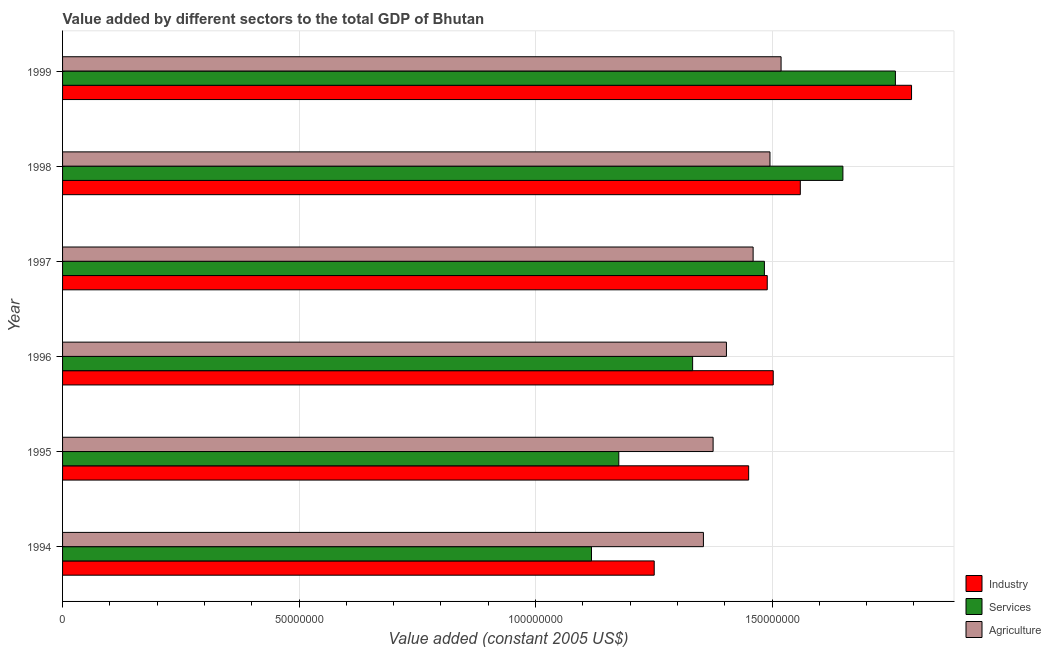Are the number of bars per tick equal to the number of legend labels?
Provide a short and direct response. Yes. Are the number of bars on each tick of the Y-axis equal?
Your answer should be compact. Yes. How many bars are there on the 2nd tick from the top?
Your response must be concise. 3. How many bars are there on the 1st tick from the bottom?
Offer a terse response. 3. What is the value added by industrial sector in 1994?
Your answer should be very brief. 1.25e+08. Across all years, what is the maximum value added by services?
Your answer should be very brief. 1.76e+08. Across all years, what is the minimum value added by agricultural sector?
Provide a short and direct response. 1.35e+08. In which year was the value added by services minimum?
Your answer should be compact. 1994. What is the total value added by services in the graph?
Ensure brevity in your answer.  8.52e+08. What is the difference between the value added by services in 1998 and that in 1999?
Your answer should be compact. -1.11e+07. What is the difference between the value added by agricultural sector in 1998 and the value added by industrial sector in 1995?
Ensure brevity in your answer.  4.51e+06. What is the average value added by industrial sector per year?
Provide a short and direct response. 1.51e+08. In the year 1996, what is the difference between the value added by services and value added by agricultural sector?
Keep it short and to the point. -7.15e+06. What is the ratio of the value added by industrial sector in 1997 to that in 1999?
Provide a short and direct response. 0.83. Is the value added by services in 1995 less than that in 1997?
Provide a succinct answer. Yes. Is the difference between the value added by services in 1996 and 1999 greater than the difference between the value added by agricultural sector in 1996 and 1999?
Provide a succinct answer. No. What is the difference between the highest and the second highest value added by industrial sector?
Offer a terse response. 2.35e+07. What is the difference between the highest and the lowest value added by agricultural sector?
Your response must be concise. 1.64e+07. Is the sum of the value added by services in 1995 and 1999 greater than the maximum value added by industrial sector across all years?
Offer a very short reply. Yes. What does the 3rd bar from the top in 1994 represents?
Your answer should be very brief. Industry. What does the 3rd bar from the bottom in 1996 represents?
Your answer should be very brief. Agriculture. How many bars are there?
Offer a terse response. 18. Are all the bars in the graph horizontal?
Provide a succinct answer. Yes. Are the values on the major ticks of X-axis written in scientific E-notation?
Ensure brevity in your answer.  No. Does the graph contain any zero values?
Your answer should be compact. No. Does the graph contain grids?
Give a very brief answer. Yes. How many legend labels are there?
Your response must be concise. 3. What is the title of the graph?
Ensure brevity in your answer.  Value added by different sectors to the total GDP of Bhutan. Does "Consumption Tax" appear as one of the legend labels in the graph?
Your answer should be very brief. No. What is the label or title of the X-axis?
Offer a terse response. Value added (constant 2005 US$). What is the label or title of the Y-axis?
Offer a terse response. Year. What is the Value added (constant 2005 US$) in Industry in 1994?
Offer a terse response. 1.25e+08. What is the Value added (constant 2005 US$) of Services in 1994?
Offer a very short reply. 1.12e+08. What is the Value added (constant 2005 US$) in Agriculture in 1994?
Offer a terse response. 1.35e+08. What is the Value added (constant 2005 US$) in Industry in 1995?
Offer a very short reply. 1.45e+08. What is the Value added (constant 2005 US$) in Services in 1995?
Your answer should be compact. 1.18e+08. What is the Value added (constant 2005 US$) of Agriculture in 1995?
Provide a short and direct response. 1.38e+08. What is the Value added (constant 2005 US$) in Industry in 1996?
Your answer should be compact. 1.50e+08. What is the Value added (constant 2005 US$) in Services in 1996?
Provide a short and direct response. 1.33e+08. What is the Value added (constant 2005 US$) of Agriculture in 1996?
Offer a terse response. 1.40e+08. What is the Value added (constant 2005 US$) of Industry in 1997?
Offer a very short reply. 1.49e+08. What is the Value added (constant 2005 US$) of Services in 1997?
Offer a very short reply. 1.48e+08. What is the Value added (constant 2005 US$) of Agriculture in 1997?
Provide a short and direct response. 1.46e+08. What is the Value added (constant 2005 US$) of Industry in 1998?
Ensure brevity in your answer.  1.56e+08. What is the Value added (constant 2005 US$) of Services in 1998?
Your answer should be compact. 1.65e+08. What is the Value added (constant 2005 US$) in Agriculture in 1998?
Give a very brief answer. 1.50e+08. What is the Value added (constant 2005 US$) in Industry in 1999?
Your response must be concise. 1.79e+08. What is the Value added (constant 2005 US$) of Services in 1999?
Your answer should be compact. 1.76e+08. What is the Value added (constant 2005 US$) in Agriculture in 1999?
Keep it short and to the point. 1.52e+08. Across all years, what is the maximum Value added (constant 2005 US$) in Industry?
Offer a very short reply. 1.79e+08. Across all years, what is the maximum Value added (constant 2005 US$) of Services?
Your answer should be very brief. 1.76e+08. Across all years, what is the maximum Value added (constant 2005 US$) of Agriculture?
Provide a short and direct response. 1.52e+08. Across all years, what is the minimum Value added (constant 2005 US$) of Industry?
Make the answer very short. 1.25e+08. Across all years, what is the minimum Value added (constant 2005 US$) of Services?
Your answer should be compact. 1.12e+08. Across all years, what is the minimum Value added (constant 2005 US$) of Agriculture?
Your response must be concise. 1.35e+08. What is the total Value added (constant 2005 US$) in Industry in the graph?
Give a very brief answer. 9.05e+08. What is the total Value added (constant 2005 US$) of Services in the graph?
Keep it short and to the point. 8.52e+08. What is the total Value added (constant 2005 US$) in Agriculture in the graph?
Provide a succinct answer. 8.61e+08. What is the difference between the Value added (constant 2005 US$) in Industry in 1994 and that in 1995?
Offer a very short reply. -2.00e+07. What is the difference between the Value added (constant 2005 US$) of Services in 1994 and that in 1995?
Your answer should be very brief. -5.77e+06. What is the difference between the Value added (constant 2005 US$) of Agriculture in 1994 and that in 1995?
Provide a succinct answer. -2.05e+06. What is the difference between the Value added (constant 2005 US$) of Industry in 1994 and that in 1996?
Provide a short and direct response. -2.52e+07. What is the difference between the Value added (constant 2005 US$) of Services in 1994 and that in 1996?
Offer a terse response. -2.14e+07. What is the difference between the Value added (constant 2005 US$) in Agriculture in 1994 and that in 1996?
Your response must be concise. -4.87e+06. What is the difference between the Value added (constant 2005 US$) in Industry in 1994 and that in 1997?
Offer a very short reply. -2.39e+07. What is the difference between the Value added (constant 2005 US$) of Services in 1994 and that in 1997?
Make the answer very short. -3.66e+07. What is the difference between the Value added (constant 2005 US$) of Agriculture in 1994 and that in 1997?
Your answer should be compact. -1.05e+07. What is the difference between the Value added (constant 2005 US$) of Industry in 1994 and that in 1998?
Offer a terse response. -3.09e+07. What is the difference between the Value added (constant 2005 US$) of Services in 1994 and that in 1998?
Ensure brevity in your answer.  -5.32e+07. What is the difference between the Value added (constant 2005 US$) of Agriculture in 1994 and that in 1998?
Make the answer very short. -1.41e+07. What is the difference between the Value added (constant 2005 US$) in Industry in 1994 and that in 1999?
Provide a short and direct response. -5.44e+07. What is the difference between the Value added (constant 2005 US$) of Services in 1994 and that in 1999?
Your answer should be very brief. -6.43e+07. What is the difference between the Value added (constant 2005 US$) of Agriculture in 1994 and that in 1999?
Keep it short and to the point. -1.64e+07. What is the difference between the Value added (constant 2005 US$) in Industry in 1995 and that in 1996?
Provide a short and direct response. -5.20e+06. What is the difference between the Value added (constant 2005 US$) in Services in 1995 and that in 1996?
Keep it short and to the point. -1.56e+07. What is the difference between the Value added (constant 2005 US$) of Agriculture in 1995 and that in 1996?
Offer a very short reply. -2.82e+06. What is the difference between the Value added (constant 2005 US$) in Industry in 1995 and that in 1997?
Your answer should be compact. -3.93e+06. What is the difference between the Value added (constant 2005 US$) of Services in 1995 and that in 1997?
Make the answer very short. -3.08e+07. What is the difference between the Value added (constant 2005 US$) in Agriculture in 1995 and that in 1997?
Provide a short and direct response. -8.46e+06. What is the difference between the Value added (constant 2005 US$) in Industry in 1995 and that in 1998?
Ensure brevity in your answer.  -1.09e+07. What is the difference between the Value added (constant 2005 US$) of Services in 1995 and that in 1998?
Provide a short and direct response. -4.74e+07. What is the difference between the Value added (constant 2005 US$) of Agriculture in 1995 and that in 1998?
Your response must be concise. -1.20e+07. What is the difference between the Value added (constant 2005 US$) in Industry in 1995 and that in 1999?
Give a very brief answer. -3.44e+07. What is the difference between the Value added (constant 2005 US$) in Services in 1995 and that in 1999?
Offer a terse response. -5.85e+07. What is the difference between the Value added (constant 2005 US$) in Agriculture in 1995 and that in 1999?
Your answer should be compact. -1.44e+07. What is the difference between the Value added (constant 2005 US$) in Industry in 1996 and that in 1997?
Offer a very short reply. 1.27e+06. What is the difference between the Value added (constant 2005 US$) in Services in 1996 and that in 1997?
Provide a succinct answer. -1.52e+07. What is the difference between the Value added (constant 2005 US$) in Agriculture in 1996 and that in 1997?
Offer a very short reply. -5.64e+06. What is the difference between the Value added (constant 2005 US$) in Industry in 1996 and that in 1998?
Offer a terse response. -5.72e+06. What is the difference between the Value added (constant 2005 US$) in Services in 1996 and that in 1998?
Offer a very short reply. -3.18e+07. What is the difference between the Value added (constant 2005 US$) in Agriculture in 1996 and that in 1998?
Provide a succinct answer. -9.20e+06. What is the difference between the Value added (constant 2005 US$) of Industry in 1996 and that in 1999?
Your answer should be compact. -2.92e+07. What is the difference between the Value added (constant 2005 US$) of Services in 1996 and that in 1999?
Offer a very short reply. -4.29e+07. What is the difference between the Value added (constant 2005 US$) in Agriculture in 1996 and that in 1999?
Ensure brevity in your answer.  -1.16e+07. What is the difference between the Value added (constant 2005 US$) of Industry in 1997 and that in 1998?
Your answer should be compact. -6.99e+06. What is the difference between the Value added (constant 2005 US$) of Services in 1997 and that in 1998?
Your answer should be compact. -1.66e+07. What is the difference between the Value added (constant 2005 US$) of Agriculture in 1997 and that in 1998?
Your answer should be very brief. -3.56e+06. What is the difference between the Value added (constant 2005 US$) in Industry in 1997 and that in 1999?
Keep it short and to the point. -3.05e+07. What is the difference between the Value added (constant 2005 US$) of Services in 1997 and that in 1999?
Make the answer very short. -2.77e+07. What is the difference between the Value added (constant 2005 US$) of Agriculture in 1997 and that in 1999?
Your answer should be compact. -5.91e+06. What is the difference between the Value added (constant 2005 US$) of Industry in 1998 and that in 1999?
Make the answer very short. -2.35e+07. What is the difference between the Value added (constant 2005 US$) of Services in 1998 and that in 1999?
Ensure brevity in your answer.  -1.11e+07. What is the difference between the Value added (constant 2005 US$) of Agriculture in 1998 and that in 1999?
Keep it short and to the point. -2.35e+06. What is the difference between the Value added (constant 2005 US$) in Industry in 1994 and the Value added (constant 2005 US$) in Services in 1995?
Make the answer very short. 7.49e+06. What is the difference between the Value added (constant 2005 US$) of Industry in 1994 and the Value added (constant 2005 US$) of Agriculture in 1995?
Ensure brevity in your answer.  -1.25e+07. What is the difference between the Value added (constant 2005 US$) in Services in 1994 and the Value added (constant 2005 US$) in Agriculture in 1995?
Your answer should be very brief. -2.57e+07. What is the difference between the Value added (constant 2005 US$) in Industry in 1994 and the Value added (constant 2005 US$) in Services in 1996?
Give a very brief answer. -8.12e+06. What is the difference between the Value added (constant 2005 US$) of Industry in 1994 and the Value added (constant 2005 US$) of Agriculture in 1996?
Keep it short and to the point. -1.53e+07. What is the difference between the Value added (constant 2005 US$) in Services in 1994 and the Value added (constant 2005 US$) in Agriculture in 1996?
Make the answer very short. -2.85e+07. What is the difference between the Value added (constant 2005 US$) of Industry in 1994 and the Value added (constant 2005 US$) of Services in 1997?
Keep it short and to the point. -2.33e+07. What is the difference between the Value added (constant 2005 US$) of Industry in 1994 and the Value added (constant 2005 US$) of Agriculture in 1997?
Make the answer very short. -2.09e+07. What is the difference between the Value added (constant 2005 US$) in Services in 1994 and the Value added (constant 2005 US$) in Agriculture in 1997?
Your response must be concise. -3.42e+07. What is the difference between the Value added (constant 2005 US$) of Industry in 1994 and the Value added (constant 2005 US$) of Services in 1998?
Offer a terse response. -3.99e+07. What is the difference between the Value added (constant 2005 US$) of Industry in 1994 and the Value added (constant 2005 US$) of Agriculture in 1998?
Provide a short and direct response. -2.45e+07. What is the difference between the Value added (constant 2005 US$) in Services in 1994 and the Value added (constant 2005 US$) in Agriculture in 1998?
Provide a succinct answer. -3.77e+07. What is the difference between the Value added (constant 2005 US$) in Industry in 1994 and the Value added (constant 2005 US$) in Services in 1999?
Provide a succinct answer. -5.10e+07. What is the difference between the Value added (constant 2005 US$) of Industry in 1994 and the Value added (constant 2005 US$) of Agriculture in 1999?
Provide a succinct answer. -2.68e+07. What is the difference between the Value added (constant 2005 US$) in Services in 1994 and the Value added (constant 2005 US$) in Agriculture in 1999?
Your response must be concise. -4.01e+07. What is the difference between the Value added (constant 2005 US$) of Industry in 1995 and the Value added (constant 2005 US$) of Services in 1996?
Offer a very short reply. 1.18e+07. What is the difference between the Value added (constant 2005 US$) of Industry in 1995 and the Value added (constant 2005 US$) of Agriculture in 1996?
Make the answer very short. 4.70e+06. What is the difference between the Value added (constant 2005 US$) in Services in 1995 and the Value added (constant 2005 US$) in Agriculture in 1996?
Ensure brevity in your answer.  -2.28e+07. What is the difference between the Value added (constant 2005 US$) of Industry in 1995 and the Value added (constant 2005 US$) of Services in 1997?
Keep it short and to the point. -3.33e+06. What is the difference between the Value added (constant 2005 US$) in Industry in 1995 and the Value added (constant 2005 US$) in Agriculture in 1997?
Your answer should be very brief. -9.45e+05. What is the difference between the Value added (constant 2005 US$) of Services in 1995 and the Value added (constant 2005 US$) of Agriculture in 1997?
Your answer should be very brief. -2.84e+07. What is the difference between the Value added (constant 2005 US$) in Industry in 1995 and the Value added (constant 2005 US$) in Services in 1998?
Provide a short and direct response. -1.99e+07. What is the difference between the Value added (constant 2005 US$) of Industry in 1995 and the Value added (constant 2005 US$) of Agriculture in 1998?
Your response must be concise. -4.51e+06. What is the difference between the Value added (constant 2005 US$) of Services in 1995 and the Value added (constant 2005 US$) of Agriculture in 1998?
Give a very brief answer. -3.20e+07. What is the difference between the Value added (constant 2005 US$) of Industry in 1995 and the Value added (constant 2005 US$) of Services in 1999?
Your answer should be very brief. -3.10e+07. What is the difference between the Value added (constant 2005 US$) of Industry in 1995 and the Value added (constant 2005 US$) of Agriculture in 1999?
Your answer should be very brief. -6.86e+06. What is the difference between the Value added (constant 2005 US$) of Services in 1995 and the Value added (constant 2005 US$) of Agriculture in 1999?
Provide a succinct answer. -3.43e+07. What is the difference between the Value added (constant 2005 US$) of Industry in 1996 and the Value added (constant 2005 US$) of Services in 1997?
Keep it short and to the point. 1.87e+06. What is the difference between the Value added (constant 2005 US$) in Industry in 1996 and the Value added (constant 2005 US$) in Agriculture in 1997?
Give a very brief answer. 4.25e+06. What is the difference between the Value added (constant 2005 US$) of Services in 1996 and the Value added (constant 2005 US$) of Agriculture in 1997?
Ensure brevity in your answer.  -1.28e+07. What is the difference between the Value added (constant 2005 US$) of Industry in 1996 and the Value added (constant 2005 US$) of Services in 1998?
Offer a terse response. -1.47e+07. What is the difference between the Value added (constant 2005 US$) of Industry in 1996 and the Value added (constant 2005 US$) of Agriculture in 1998?
Provide a succinct answer. 6.93e+05. What is the difference between the Value added (constant 2005 US$) of Services in 1996 and the Value added (constant 2005 US$) of Agriculture in 1998?
Your answer should be very brief. -1.64e+07. What is the difference between the Value added (constant 2005 US$) in Industry in 1996 and the Value added (constant 2005 US$) in Services in 1999?
Make the answer very short. -2.58e+07. What is the difference between the Value added (constant 2005 US$) of Industry in 1996 and the Value added (constant 2005 US$) of Agriculture in 1999?
Give a very brief answer. -1.66e+06. What is the difference between the Value added (constant 2005 US$) of Services in 1996 and the Value added (constant 2005 US$) of Agriculture in 1999?
Your answer should be very brief. -1.87e+07. What is the difference between the Value added (constant 2005 US$) in Industry in 1997 and the Value added (constant 2005 US$) in Services in 1998?
Offer a terse response. -1.60e+07. What is the difference between the Value added (constant 2005 US$) in Industry in 1997 and the Value added (constant 2005 US$) in Agriculture in 1998?
Make the answer very short. -5.73e+05. What is the difference between the Value added (constant 2005 US$) of Services in 1997 and the Value added (constant 2005 US$) of Agriculture in 1998?
Provide a short and direct response. -1.18e+06. What is the difference between the Value added (constant 2005 US$) in Industry in 1997 and the Value added (constant 2005 US$) in Services in 1999?
Provide a succinct answer. -2.71e+07. What is the difference between the Value added (constant 2005 US$) in Industry in 1997 and the Value added (constant 2005 US$) in Agriculture in 1999?
Keep it short and to the point. -2.92e+06. What is the difference between the Value added (constant 2005 US$) in Services in 1997 and the Value added (constant 2005 US$) in Agriculture in 1999?
Provide a short and direct response. -3.53e+06. What is the difference between the Value added (constant 2005 US$) in Industry in 1998 and the Value added (constant 2005 US$) in Services in 1999?
Your answer should be compact. -2.01e+07. What is the difference between the Value added (constant 2005 US$) in Industry in 1998 and the Value added (constant 2005 US$) in Agriculture in 1999?
Give a very brief answer. 4.07e+06. What is the difference between the Value added (constant 2005 US$) in Services in 1998 and the Value added (constant 2005 US$) in Agriculture in 1999?
Your answer should be compact. 1.31e+07. What is the average Value added (constant 2005 US$) of Industry per year?
Give a very brief answer. 1.51e+08. What is the average Value added (constant 2005 US$) of Services per year?
Your response must be concise. 1.42e+08. What is the average Value added (constant 2005 US$) in Agriculture per year?
Provide a short and direct response. 1.43e+08. In the year 1994, what is the difference between the Value added (constant 2005 US$) of Industry and Value added (constant 2005 US$) of Services?
Your answer should be compact. 1.33e+07. In the year 1994, what is the difference between the Value added (constant 2005 US$) of Industry and Value added (constant 2005 US$) of Agriculture?
Your answer should be compact. -1.04e+07. In the year 1994, what is the difference between the Value added (constant 2005 US$) of Services and Value added (constant 2005 US$) of Agriculture?
Offer a very short reply. -2.37e+07. In the year 1995, what is the difference between the Value added (constant 2005 US$) in Industry and Value added (constant 2005 US$) in Services?
Offer a terse response. 2.75e+07. In the year 1995, what is the difference between the Value added (constant 2005 US$) of Industry and Value added (constant 2005 US$) of Agriculture?
Your answer should be compact. 7.51e+06. In the year 1995, what is the difference between the Value added (constant 2005 US$) in Services and Value added (constant 2005 US$) in Agriculture?
Provide a succinct answer. -1.99e+07. In the year 1996, what is the difference between the Value added (constant 2005 US$) in Industry and Value added (constant 2005 US$) in Services?
Your answer should be very brief. 1.70e+07. In the year 1996, what is the difference between the Value added (constant 2005 US$) of Industry and Value added (constant 2005 US$) of Agriculture?
Your answer should be compact. 9.90e+06. In the year 1996, what is the difference between the Value added (constant 2005 US$) of Services and Value added (constant 2005 US$) of Agriculture?
Offer a terse response. -7.15e+06. In the year 1997, what is the difference between the Value added (constant 2005 US$) of Industry and Value added (constant 2005 US$) of Services?
Keep it short and to the point. 6.03e+05. In the year 1997, what is the difference between the Value added (constant 2005 US$) in Industry and Value added (constant 2005 US$) in Agriculture?
Provide a short and direct response. 2.99e+06. In the year 1997, what is the difference between the Value added (constant 2005 US$) in Services and Value added (constant 2005 US$) in Agriculture?
Ensure brevity in your answer.  2.38e+06. In the year 1998, what is the difference between the Value added (constant 2005 US$) in Industry and Value added (constant 2005 US$) in Services?
Ensure brevity in your answer.  -9.00e+06. In the year 1998, what is the difference between the Value added (constant 2005 US$) in Industry and Value added (constant 2005 US$) in Agriculture?
Give a very brief answer. 6.42e+06. In the year 1998, what is the difference between the Value added (constant 2005 US$) in Services and Value added (constant 2005 US$) in Agriculture?
Offer a very short reply. 1.54e+07. In the year 1999, what is the difference between the Value added (constant 2005 US$) of Industry and Value added (constant 2005 US$) of Services?
Ensure brevity in your answer.  3.41e+06. In the year 1999, what is the difference between the Value added (constant 2005 US$) in Industry and Value added (constant 2005 US$) in Agriculture?
Give a very brief answer. 2.76e+07. In the year 1999, what is the difference between the Value added (constant 2005 US$) in Services and Value added (constant 2005 US$) in Agriculture?
Your response must be concise. 2.42e+07. What is the ratio of the Value added (constant 2005 US$) of Industry in 1994 to that in 1995?
Give a very brief answer. 0.86. What is the ratio of the Value added (constant 2005 US$) in Services in 1994 to that in 1995?
Provide a succinct answer. 0.95. What is the ratio of the Value added (constant 2005 US$) in Agriculture in 1994 to that in 1995?
Offer a terse response. 0.99. What is the ratio of the Value added (constant 2005 US$) in Industry in 1994 to that in 1996?
Ensure brevity in your answer.  0.83. What is the ratio of the Value added (constant 2005 US$) in Services in 1994 to that in 1996?
Keep it short and to the point. 0.84. What is the ratio of the Value added (constant 2005 US$) of Agriculture in 1994 to that in 1996?
Provide a short and direct response. 0.97. What is the ratio of the Value added (constant 2005 US$) in Industry in 1994 to that in 1997?
Your answer should be compact. 0.84. What is the ratio of the Value added (constant 2005 US$) of Services in 1994 to that in 1997?
Your answer should be compact. 0.75. What is the ratio of the Value added (constant 2005 US$) in Agriculture in 1994 to that in 1997?
Ensure brevity in your answer.  0.93. What is the ratio of the Value added (constant 2005 US$) in Industry in 1994 to that in 1998?
Offer a terse response. 0.8. What is the ratio of the Value added (constant 2005 US$) of Services in 1994 to that in 1998?
Your answer should be very brief. 0.68. What is the ratio of the Value added (constant 2005 US$) in Agriculture in 1994 to that in 1998?
Your response must be concise. 0.91. What is the ratio of the Value added (constant 2005 US$) in Industry in 1994 to that in 1999?
Provide a short and direct response. 0.7. What is the ratio of the Value added (constant 2005 US$) in Services in 1994 to that in 1999?
Make the answer very short. 0.64. What is the ratio of the Value added (constant 2005 US$) of Agriculture in 1994 to that in 1999?
Offer a terse response. 0.89. What is the ratio of the Value added (constant 2005 US$) in Industry in 1995 to that in 1996?
Your response must be concise. 0.97. What is the ratio of the Value added (constant 2005 US$) of Services in 1995 to that in 1996?
Ensure brevity in your answer.  0.88. What is the ratio of the Value added (constant 2005 US$) of Agriculture in 1995 to that in 1996?
Offer a terse response. 0.98. What is the ratio of the Value added (constant 2005 US$) in Industry in 1995 to that in 1997?
Provide a succinct answer. 0.97. What is the ratio of the Value added (constant 2005 US$) of Services in 1995 to that in 1997?
Offer a very short reply. 0.79. What is the ratio of the Value added (constant 2005 US$) in Agriculture in 1995 to that in 1997?
Keep it short and to the point. 0.94. What is the ratio of the Value added (constant 2005 US$) in Services in 1995 to that in 1998?
Your answer should be very brief. 0.71. What is the ratio of the Value added (constant 2005 US$) of Agriculture in 1995 to that in 1998?
Give a very brief answer. 0.92. What is the ratio of the Value added (constant 2005 US$) in Industry in 1995 to that in 1999?
Offer a very short reply. 0.81. What is the ratio of the Value added (constant 2005 US$) of Services in 1995 to that in 1999?
Offer a very short reply. 0.67. What is the ratio of the Value added (constant 2005 US$) in Agriculture in 1995 to that in 1999?
Offer a terse response. 0.91. What is the ratio of the Value added (constant 2005 US$) of Industry in 1996 to that in 1997?
Your answer should be very brief. 1.01. What is the ratio of the Value added (constant 2005 US$) in Services in 1996 to that in 1997?
Your response must be concise. 0.9. What is the ratio of the Value added (constant 2005 US$) in Agriculture in 1996 to that in 1997?
Your response must be concise. 0.96. What is the ratio of the Value added (constant 2005 US$) in Industry in 1996 to that in 1998?
Your answer should be very brief. 0.96. What is the ratio of the Value added (constant 2005 US$) in Services in 1996 to that in 1998?
Your answer should be very brief. 0.81. What is the ratio of the Value added (constant 2005 US$) of Agriculture in 1996 to that in 1998?
Your answer should be compact. 0.94. What is the ratio of the Value added (constant 2005 US$) in Industry in 1996 to that in 1999?
Offer a very short reply. 0.84. What is the ratio of the Value added (constant 2005 US$) of Services in 1996 to that in 1999?
Make the answer very short. 0.76. What is the ratio of the Value added (constant 2005 US$) of Agriculture in 1996 to that in 1999?
Your response must be concise. 0.92. What is the ratio of the Value added (constant 2005 US$) in Industry in 1997 to that in 1998?
Keep it short and to the point. 0.96. What is the ratio of the Value added (constant 2005 US$) of Services in 1997 to that in 1998?
Your response must be concise. 0.9. What is the ratio of the Value added (constant 2005 US$) in Agriculture in 1997 to that in 1998?
Provide a succinct answer. 0.98. What is the ratio of the Value added (constant 2005 US$) of Industry in 1997 to that in 1999?
Make the answer very short. 0.83. What is the ratio of the Value added (constant 2005 US$) of Services in 1997 to that in 1999?
Your response must be concise. 0.84. What is the ratio of the Value added (constant 2005 US$) of Agriculture in 1997 to that in 1999?
Your response must be concise. 0.96. What is the ratio of the Value added (constant 2005 US$) in Industry in 1998 to that in 1999?
Provide a short and direct response. 0.87. What is the ratio of the Value added (constant 2005 US$) in Services in 1998 to that in 1999?
Offer a terse response. 0.94. What is the ratio of the Value added (constant 2005 US$) in Agriculture in 1998 to that in 1999?
Your answer should be compact. 0.98. What is the difference between the highest and the second highest Value added (constant 2005 US$) in Industry?
Your response must be concise. 2.35e+07. What is the difference between the highest and the second highest Value added (constant 2005 US$) of Services?
Offer a terse response. 1.11e+07. What is the difference between the highest and the second highest Value added (constant 2005 US$) in Agriculture?
Offer a terse response. 2.35e+06. What is the difference between the highest and the lowest Value added (constant 2005 US$) of Industry?
Ensure brevity in your answer.  5.44e+07. What is the difference between the highest and the lowest Value added (constant 2005 US$) in Services?
Provide a short and direct response. 6.43e+07. What is the difference between the highest and the lowest Value added (constant 2005 US$) of Agriculture?
Provide a succinct answer. 1.64e+07. 